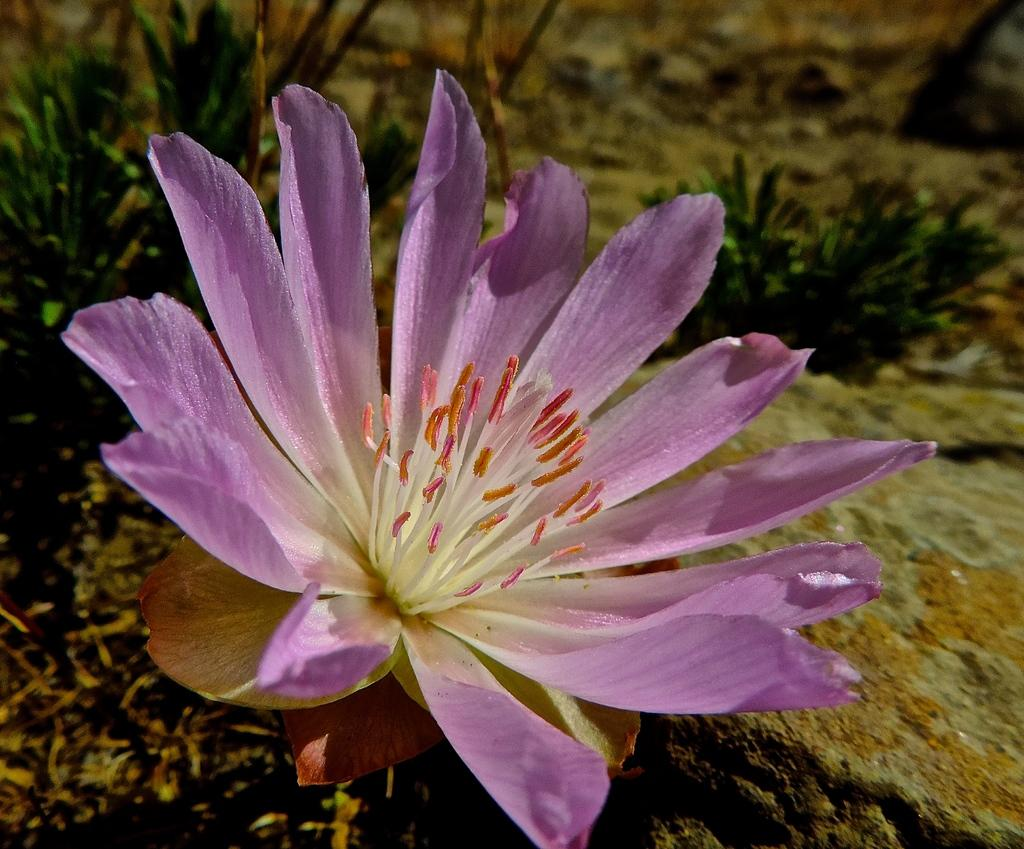What is the main subject of the image? There is a flower in the image. What can be seen behind the flower? There are plants visible behind the flower. How would you describe the background of the image? The background of the image is blurred. What is located on the right side of the image? There is a rock on the right side of the image. Where can you find the glue in the image? There is no glue present in the image. What type of market is visible in the image? There is no market visible in the image; it features a flower, plants, a blurred background, and a rock. 